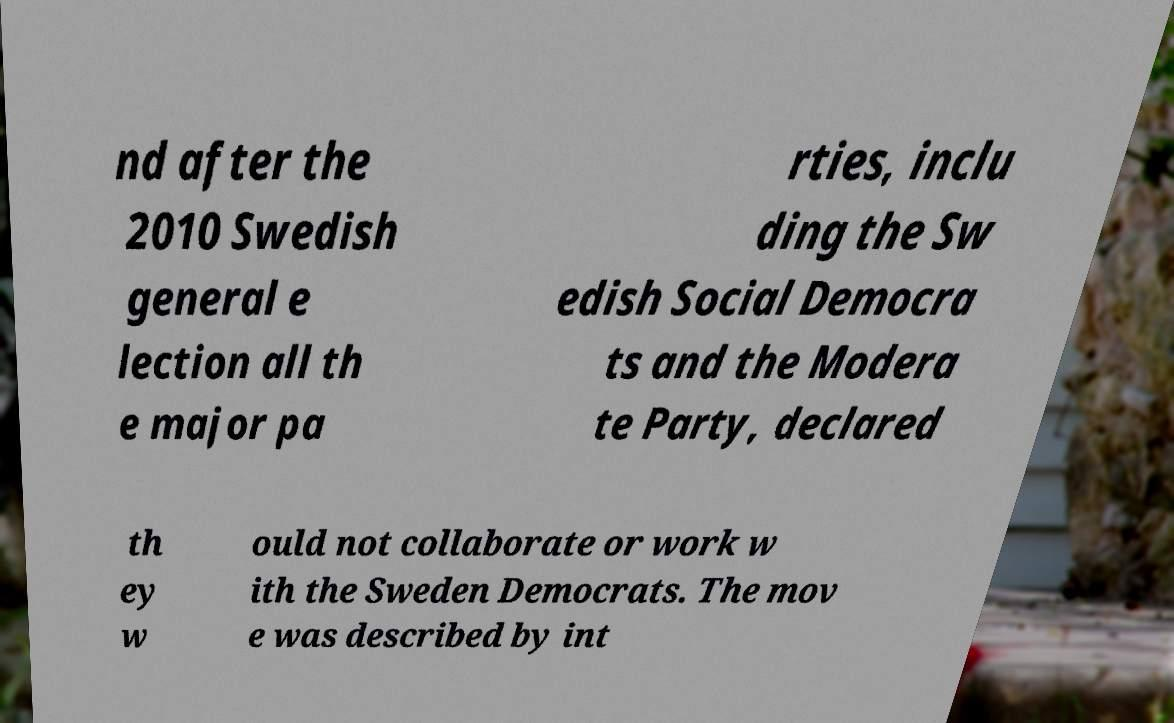I need the written content from this picture converted into text. Can you do that? nd after the 2010 Swedish general e lection all th e major pa rties, inclu ding the Sw edish Social Democra ts and the Modera te Party, declared th ey w ould not collaborate or work w ith the Sweden Democrats. The mov e was described by int 